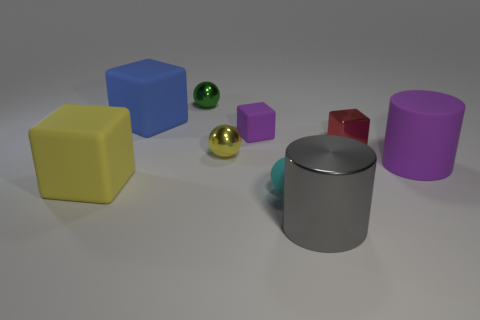Can you estimate the number of objects in this image? Sure, there are eight objects in total in this image. They consist of two cubes, one sphere, two cylinders, and three other geometric shapes that are not clearly visible from this angle. 